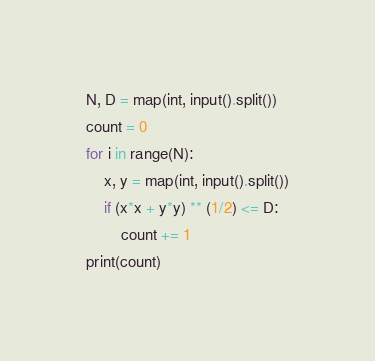Convert code to text. <code><loc_0><loc_0><loc_500><loc_500><_Python_>N, D = map(int, input().split())
count = 0
for i in range(N):
    x, y = map(int, input().split())
    if (x*x + y*y) ** (1/2) <= D:
        count += 1
print(count)</code> 